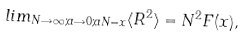Convert formula to latex. <formula><loc_0><loc_0><loc_500><loc_500>l i m _ { N \rightarrow \infty ; a \rightarrow 0 ; a N = x } \langle R ^ { 2 } \rangle = N ^ { 2 } F ( x ) ,</formula> 